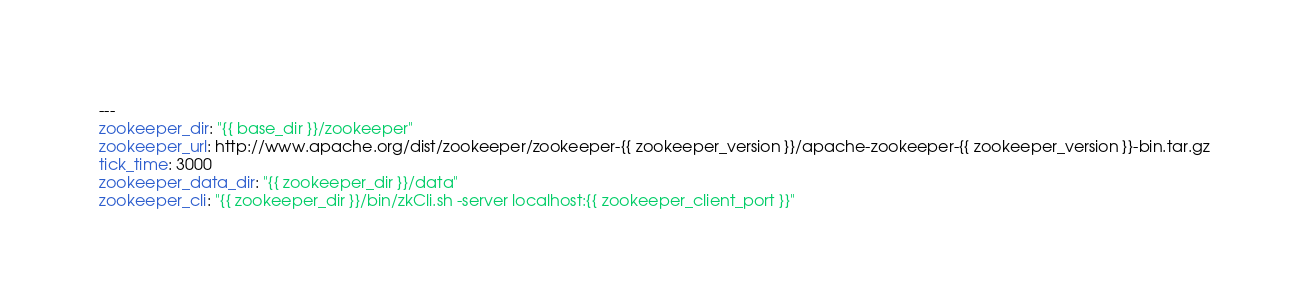<code> <loc_0><loc_0><loc_500><loc_500><_YAML_>---
zookeeper_dir: "{{ base_dir }}/zookeeper"
zookeeper_url: http://www.apache.org/dist/zookeeper/zookeeper-{{ zookeeper_version }}/apache-zookeeper-{{ zookeeper_version }}-bin.tar.gz
tick_time: 3000
zookeeper_data_dir: "{{ zookeeper_dir }}/data"
zookeeper_cli: "{{ zookeeper_dir }}/bin/zkCli.sh -server localhost:{{ zookeeper_client_port }}"
</code> 